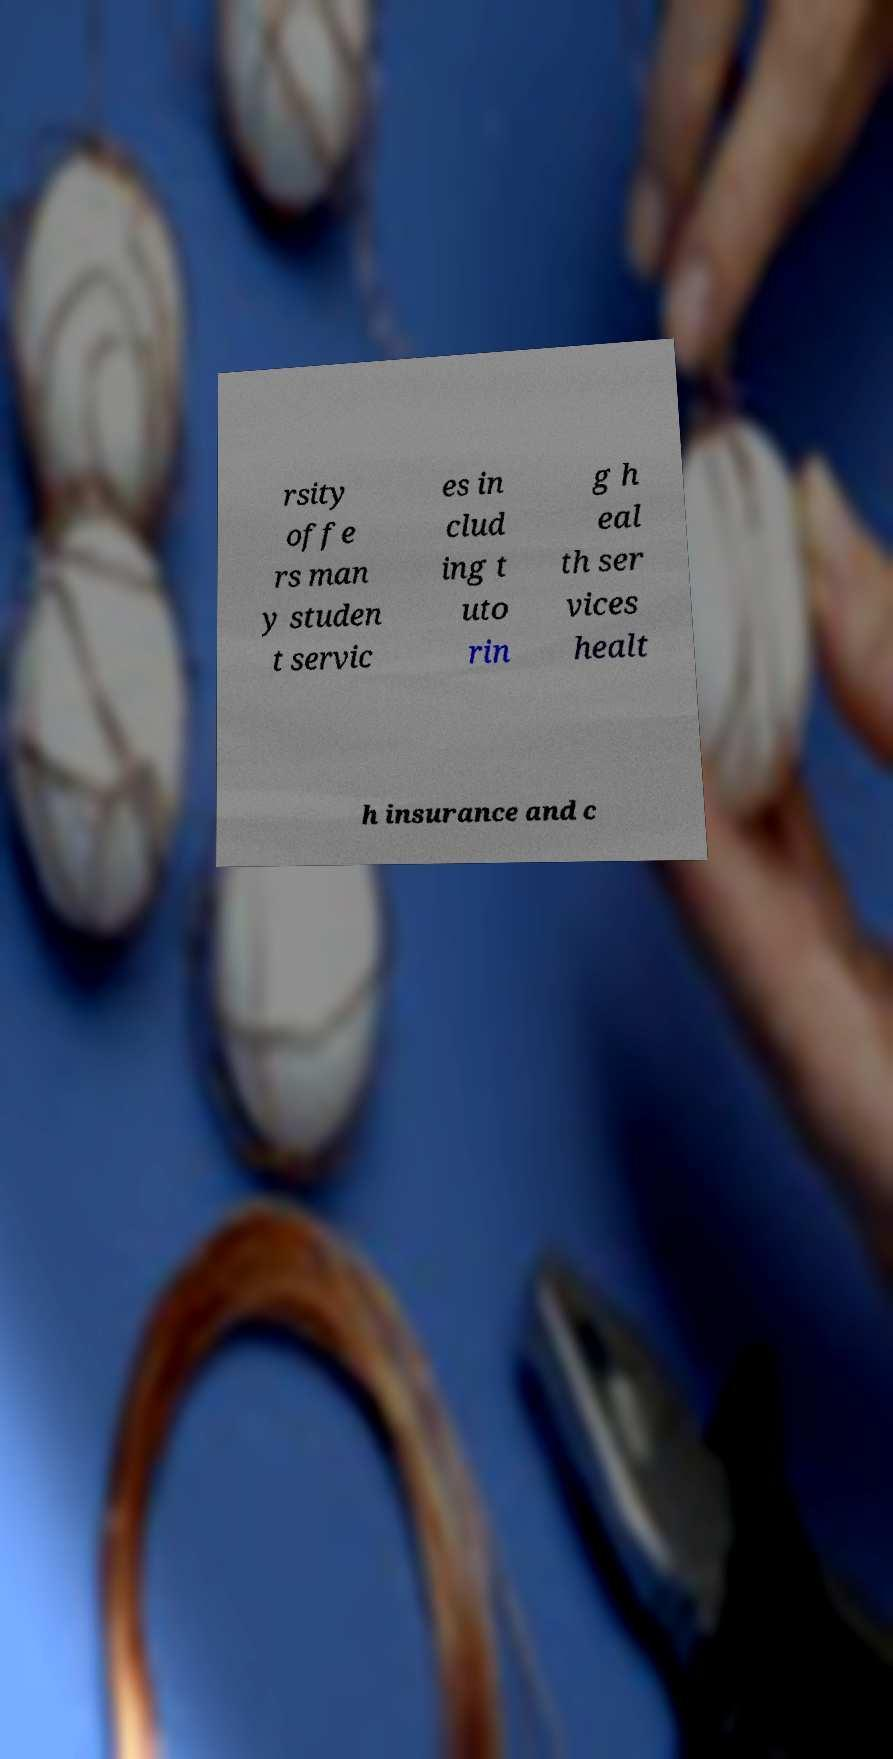There's text embedded in this image that I need extracted. Can you transcribe it verbatim? rsity offe rs man y studen t servic es in clud ing t uto rin g h eal th ser vices healt h insurance and c 